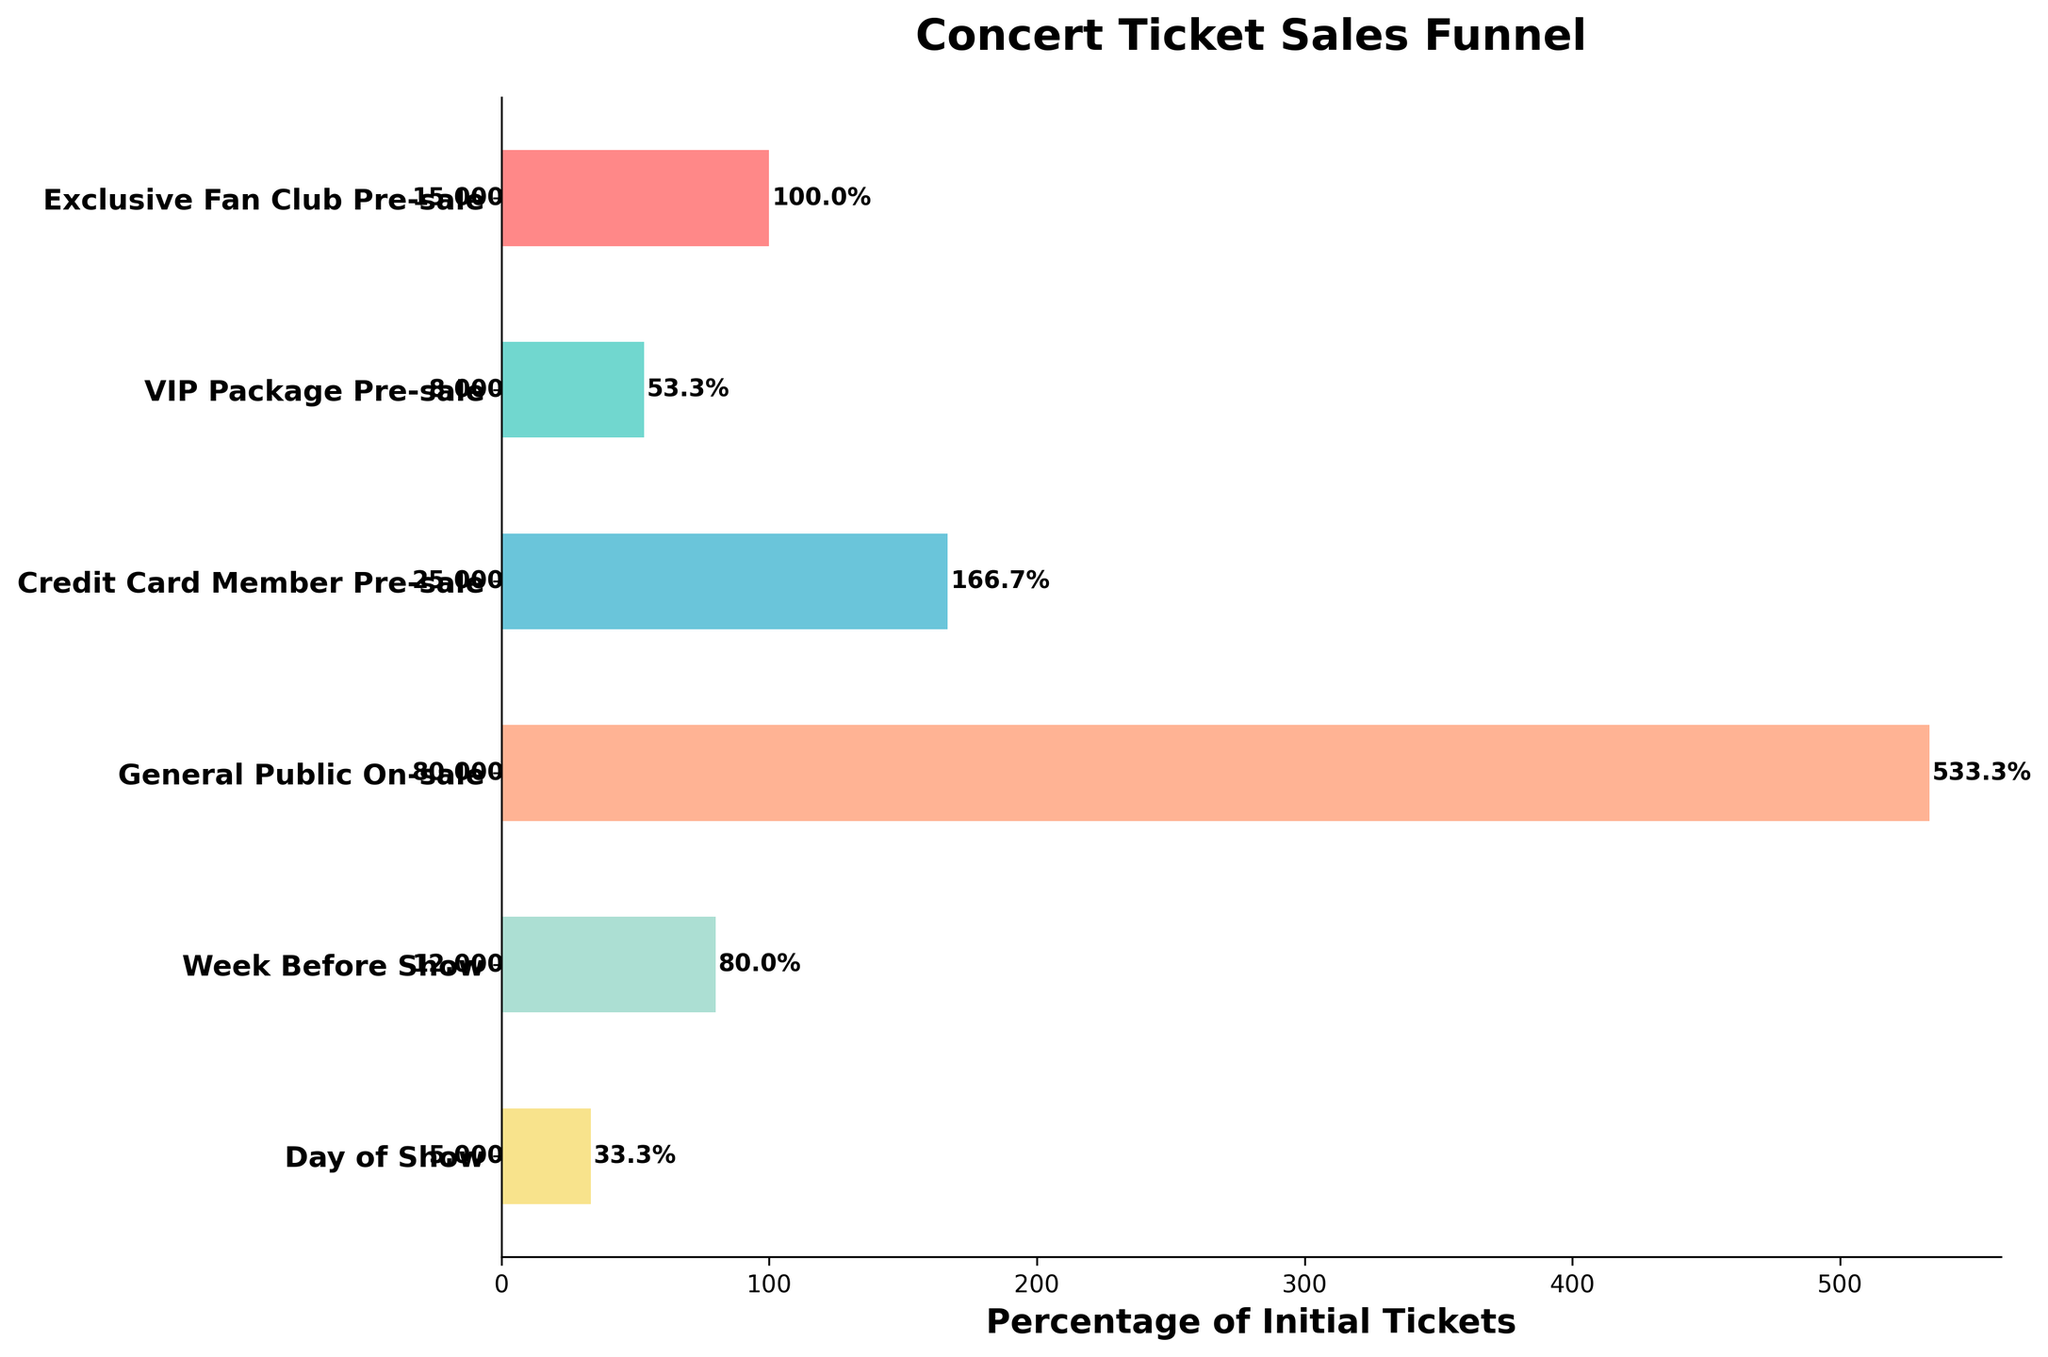What is the title of the chart? The title is typically located at the top of the chart and is meant to give an overview of what the chart represents. Here, it clearly states what data is being visualized.
Answer: Concert Ticket Sales Funnel How many stages are in the ticket sales funnel? Count the distinct stages indicated on the y-axis of the funnel chart. Each of these stages represents a point in the sales process.
Answer: 6 What percentage of initial tickets were sold during the General Public On-sale stage? Locate the General Public On-sale stage on the y-axis, then find its corresponding percentage on the x-axis and from the labels.
Answer: 533.3% Which stage had the highest number of tickets sold? Compare the numerical ticket values associated with each stage. The stage with the largest number is the one with the highest sales.
Answer: General Public On-sale What is the total number of tickets sold in the Exclusive Fan Club Pre-sale and VIP Package Pre-sale stages combined? Add the number of tickets sold during the Exclusive Fan Club Pre-sale and VIP Package Pre-sale stages.
Answer: 23,000 What is the difference in tickets sold between the Credit Card Member Pre-sale and the Day of Show stages? Subtract the number of tickets sold during the Day of Show stage from the Credit Card Member Pre-sale stage to find the difference.
Answer: 20,000 Which stage contributed the lowest percentage of initial tickets? Identify the stage with the smallest percentage value on the funnel chart.
Answer: Day of Show How does the number of tickets sold on the Day of Show stage compare to the Week Before Show stage? Compare the numerical ticket values for the Day of Show and Week Before Show stages.
Answer: Day of Show has fewer tickets sold What is the combined percentage of tickets sold in the Week Before Show and Day of Show stages relative to the initial tickets? Find the percentages for both stages and add them together to get the combined percentage.
Answer: 113.3% What trend can be observed in the number of tickets sold as it approaches the day of the show? Look at the ticket numbers across the stages from pre-sale to the day of the show and determine if there's an increasing or decreasing pattern.
Answer: Decreasing trend 